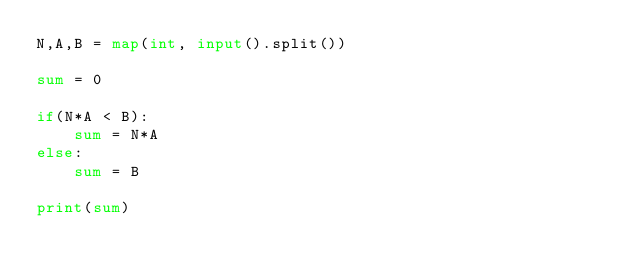Convert code to text. <code><loc_0><loc_0><loc_500><loc_500><_Python_>N,A,B = map(int, input().split())

sum = 0

if(N*A < B):
    sum = N*A
else:
    sum = B

print(sum)</code> 